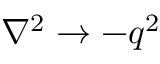Convert formula to latex. <formula><loc_0><loc_0><loc_500><loc_500>\nabla ^ { 2 } \rightarrow - q ^ { 2 }</formula> 